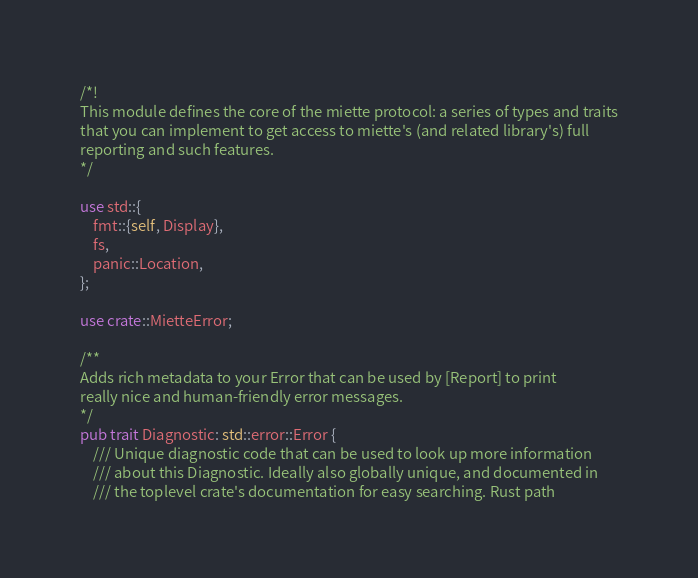<code> <loc_0><loc_0><loc_500><loc_500><_Rust_>/*!
This module defines the core of the miette protocol: a series of types and traits
that you can implement to get access to miette's (and related library's) full
reporting and such features.
*/

use std::{
    fmt::{self, Display},
    fs,
    panic::Location,
};

use crate::MietteError;

/**
Adds rich metadata to your Error that can be used by [Report] to print
really nice and human-friendly error messages.
*/
pub trait Diagnostic: std::error::Error {
    /// Unique diagnostic code that can be used to look up more information
    /// about this Diagnostic. Ideally also globally unique, and documented in
    /// the toplevel crate's documentation for easy searching. Rust path</code> 